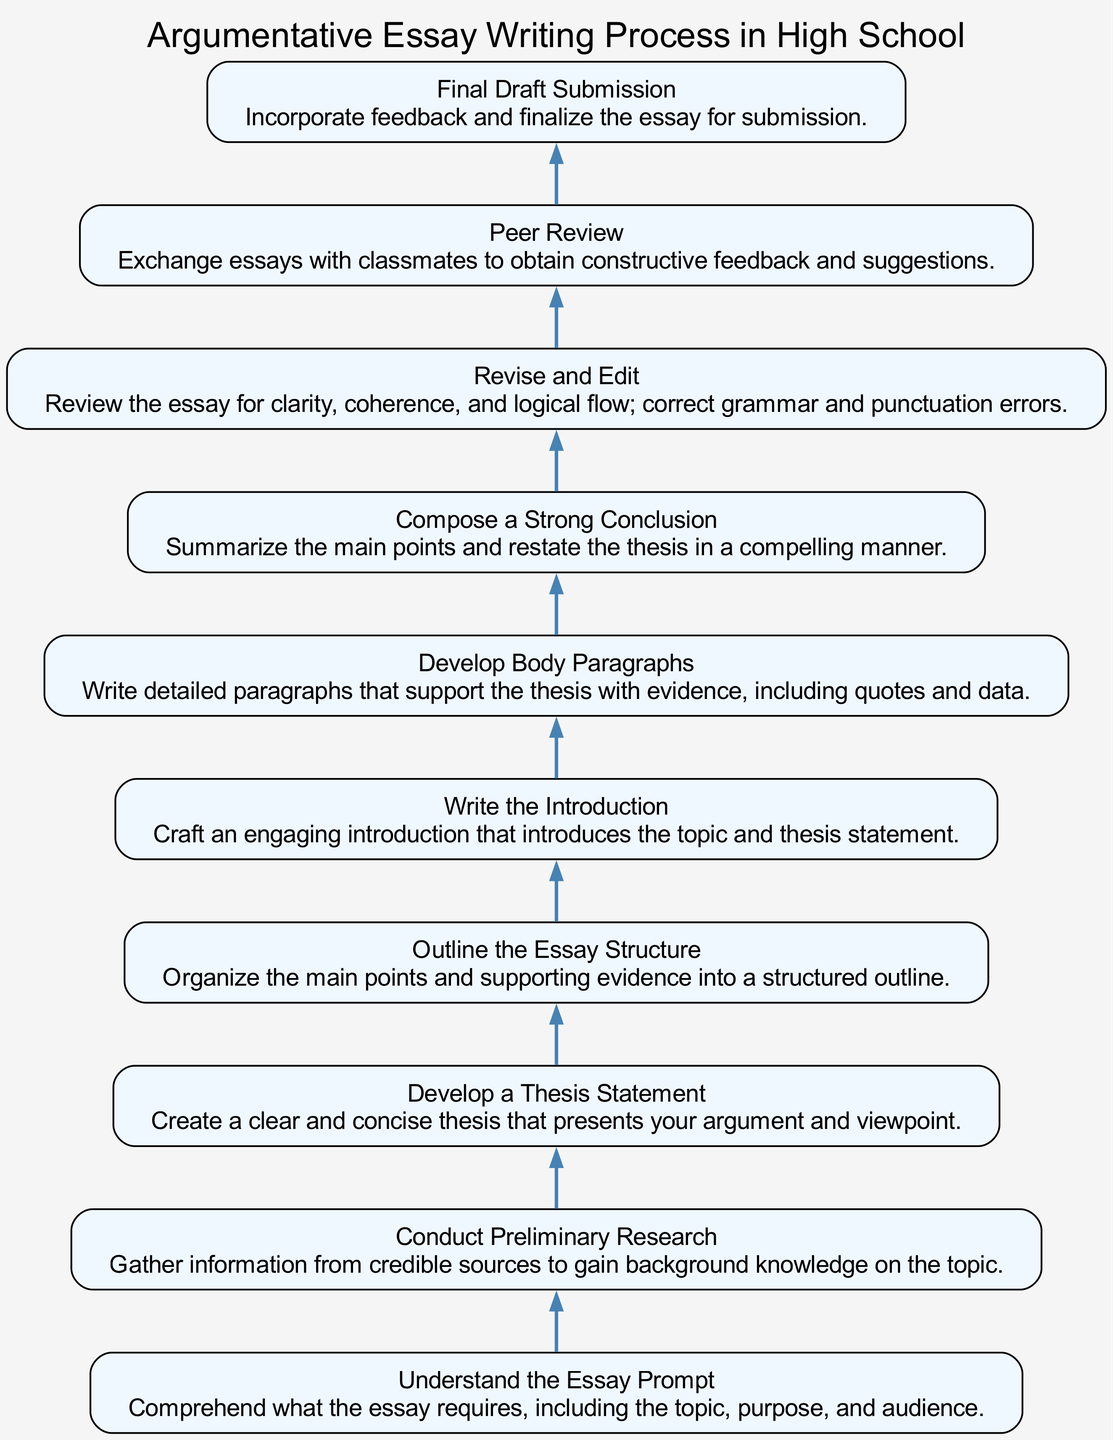What is the first step of the argumentative essay writing process? The diagram shows that the first step, as indicated at the bottom, is "Understand the Essay Prompt." This is the foundational stage where the writer comprehends the topic, purpose, and audience of the essay.
Answer: Understand the Essay Prompt How many steps are there in the process? By counting all the nodes listed in the diagram from bottom to top, there are a total of 10 distinct steps in the argumentative essay writing process.
Answer: 10 What comes after developing a thesis statement? According to the flow of the diagram, directly above "Develop a Thesis Statement," the next step to follow in the process is "Outline the Essay Structure." This shows the sequential requirement of organizing the essay after establishing a central argument.
Answer: Outline the Essay Structure What is the last step before final draft submission? The diagram illustrates that the step just prior to "Final Draft Submission" is "Peer Review." This indicates that receiving peer feedback is essential before completing the final version of the essay.
Answer: Peer Review What type of information is gathered in the preliminary research step? The step "Conduct Preliminary Research" focuses on gathering information from credible sources, which is essential for establishing background knowledge on the topic. This systematic collection of information sets the stage for further steps in the writing process.
Answer: Information from credible sources What is the purpose of the revision and editing step? The flow chart specifies that the purpose of the "Revise and Edit" step is to review the essay for clarity, coherence, and logical flow, while also correcting any grammar and punctuation errors. This ensures the essay is polished and well-prepared for submission.
Answer: To review for clarity, coherence, and correct errors Which step involves crafting an engaging introduction? The step that directly addresses creating an introduction is "Write the Introduction," which is outlined in the diagram as essential for introducing the topic and thesis statement in an engaging manner.
Answer: Write the Introduction How does the conclusion relate to the thesis? In the flow of the diagram, the step "Compose a Strong Conclusion" emphasizes summarizing the main points and restating the thesis. This shows that a strong conclusion reinforces the argument presented throughout the essay.
Answer: Restate the thesis What is required during the peer review process? The "Peer Review" step in the diagram requires exchanging essays with classmates to obtain constructive feedback and suggestions, emphasizing the importance of collaborative improvement in writing.
Answer: Exchange essays for feedback 